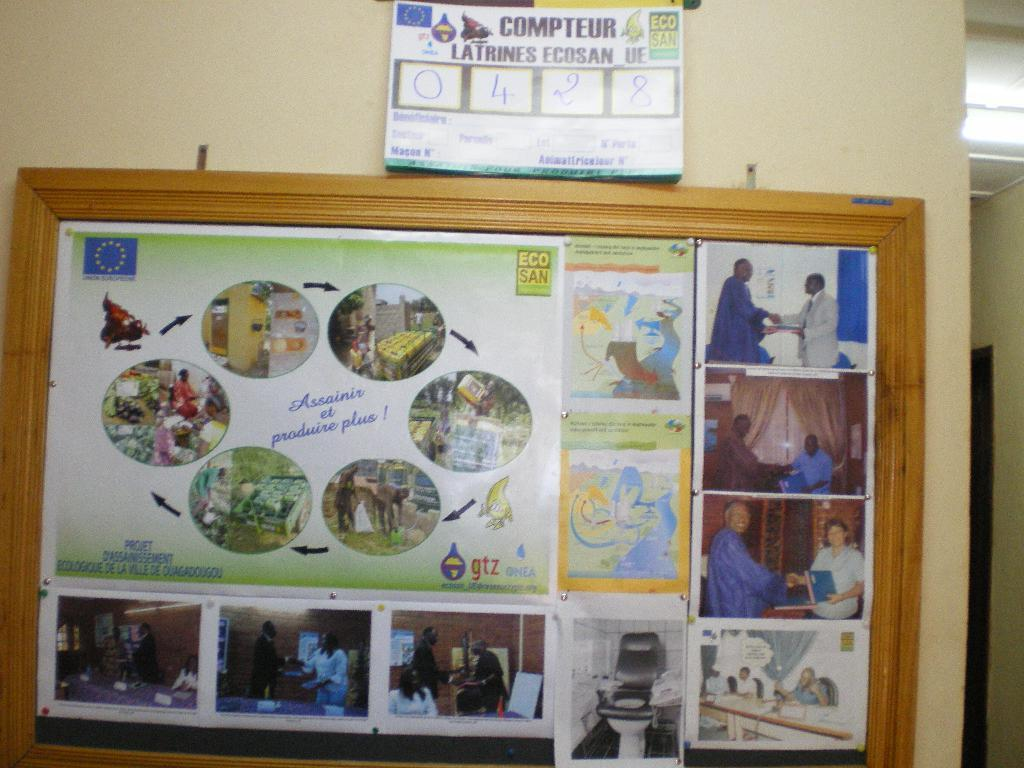<image>
Write a terse but informative summary of the picture. A framed billboard with several posters with a sign above displaying the number 0428. 